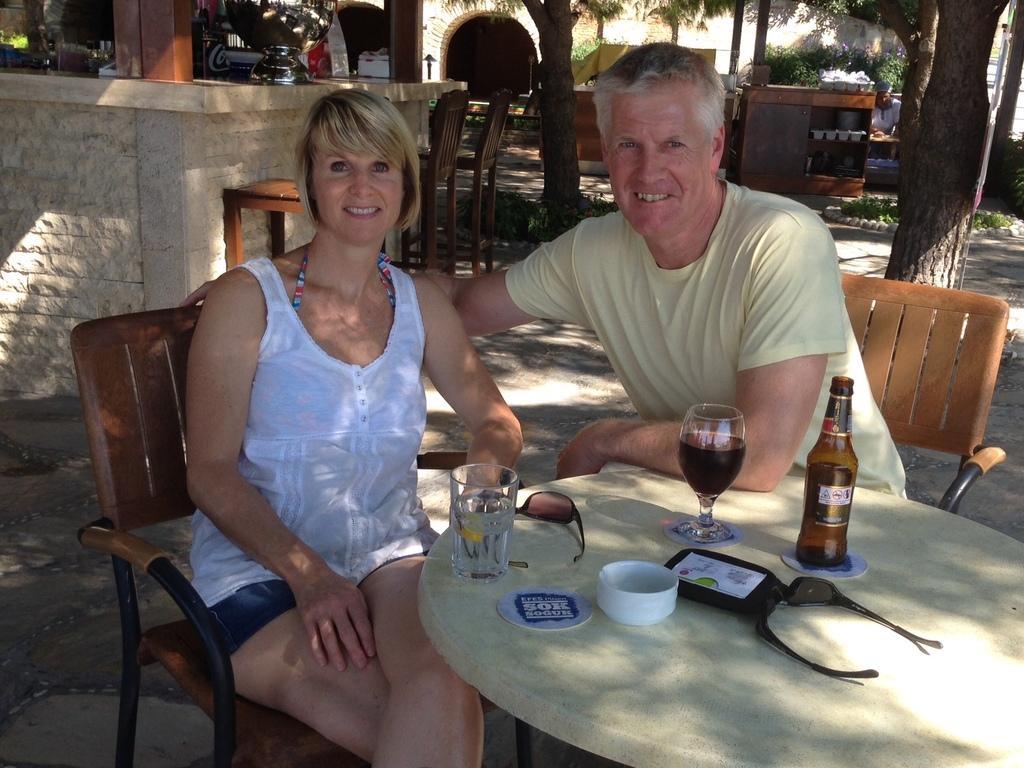Can you describe this image briefly? On the background we can see a tunnel and trees and a hoarding. This is a wall. Here we can see a man and a women sitting on chairs in front of a table and they hold a smile on their faces and on the table we can see goggles, box, cup, glasses and a bottle. 